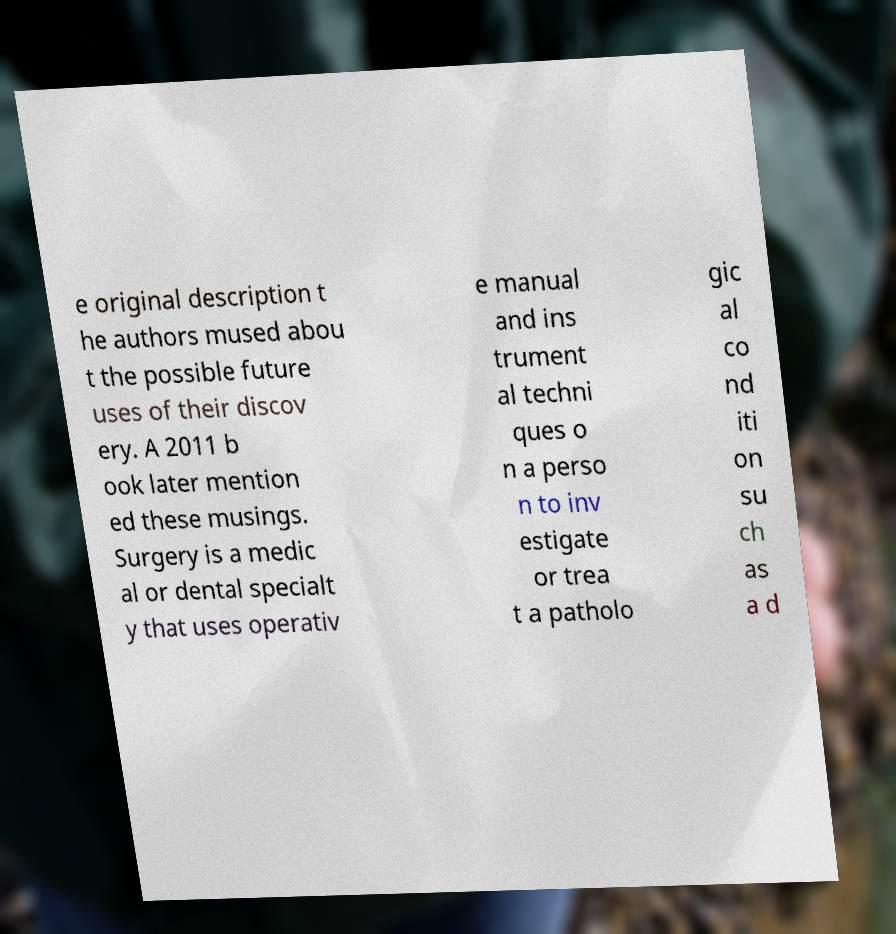There's text embedded in this image that I need extracted. Can you transcribe it verbatim? e original description t he authors mused abou t the possible future uses of their discov ery. A 2011 b ook later mention ed these musings. Surgery is a medic al or dental specialt y that uses operativ e manual and ins trument al techni ques o n a perso n to inv estigate or trea t a patholo gic al co nd iti on su ch as a d 